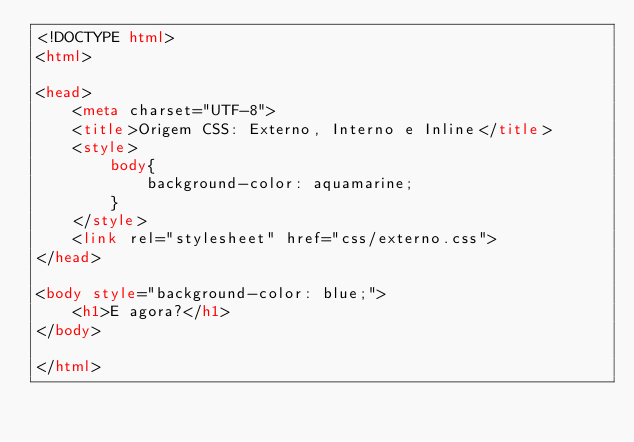Convert code to text. <code><loc_0><loc_0><loc_500><loc_500><_HTML_><!DOCTYPE html>
<html>

<head>
    <meta charset="UTF-8">
    <title>Origem CSS: Externo, Interno e Inline</title>
    <style>
        body{
            background-color: aquamarine;
        }
    </style>
    <link rel="stylesheet" href="css/externo.css">
</head>

<body style="background-color: blue;">
    <h1>E agora?</h1>
</body>

</html></code> 